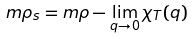<formula> <loc_0><loc_0><loc_500><loc_500>m \rho _ { s } = m \rho - \lim _ { q \to 0 } \chi _ { T } ( { q } )</formula> 